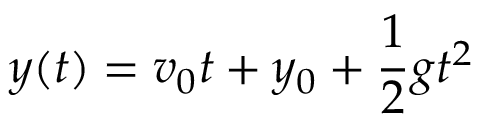<formula> <loc_0><loc_0><loc_500><loc_500>y ( t ) = v _ { 0 } t + y _ { 0 } + { \frac { 1 } { 2 } } g t ^ { 2 }</formula> 